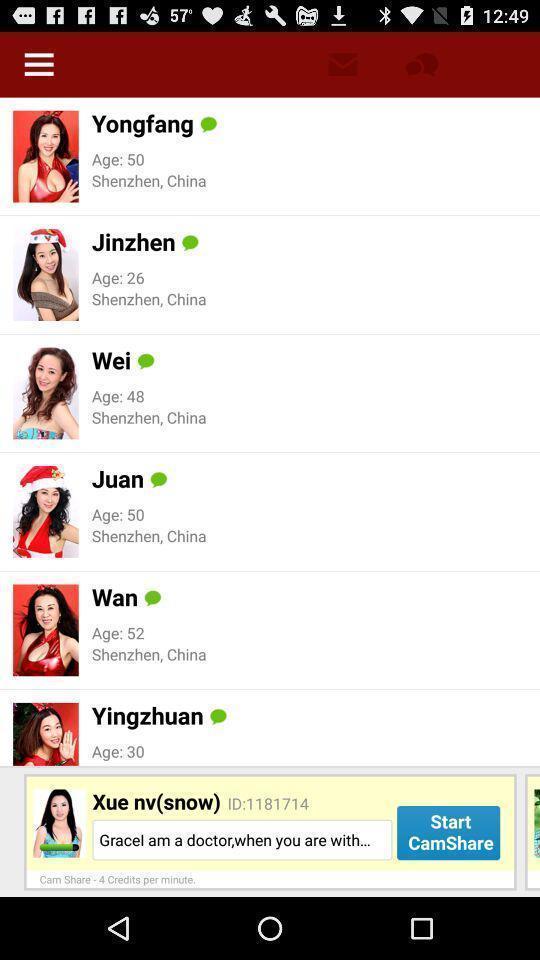Explain what's happening in this screen capture. Page showing the various profile details. 